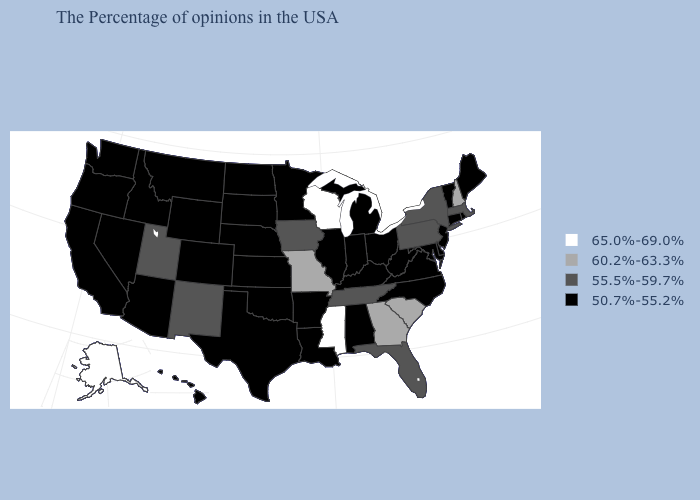Which states hav the highest value in the West?
Write a very short answer. Alaska. Name the states that have a value in the range 50.7%-55.2%?
Write a very short answer. Maine, Rhode Island, Vermont, Connecticut, New Jersey, Delaware, Maryland, Virginia, North Carolina, West Virginia, Ohio, Michigan, Kentucky, Indiana, Alabama, Illinois, Louisiana, Arkansas, Minnesota, Kansas, Nebraska, Oklahoma, Texas, South Dakota, North Dakota, Wyoming, Colorado, Montana, Arizona, Idaho, Nevada, California, Washington, Oregon, Hawaii. Does Kentucky have a lower value than Iowa?
Keep it brief. Yes. Does Michigan have the lowest value in the MidWest?
Answer briefly. Yes. Does Mississippi have the highest value in the USA?
Be succinct. Yes. Does Ohio have a lower value than Texas?
Quick response, please. No. What is the value of California?
Quick response, please. 50.7%-55.2%. What is the lowest value in the West?
Concise answer only. 50.7%-55.2%. Which states have the lowest value in the South?
Answer briefly. Delaware, Maryland, Virginia, North Carolina, West Virginia, Kentucky, Alabama, Louisiana, Arkansas, Oklahoma, Texas. What is the value of Michigan?
Be succinct. 50.7%-55.2%. Which states have the lowest value in the USA?
Keep it brief. Maine, Rhode Island, Vermont, Connecticut, New Jersey, Delaware, Maryland, Virginia, North Carolina, West Virginia, Ohio, Michigan, Kentucky, Indiana, Alabama, Illinois, Louisiana, Arkansas, Minnesota, Kansas, Nebraska, Oklahoma, Texas, South Dakota, North Dakota, Wyoming, Colorado, Montana, Arizona, Idaho, Nevada, California, Washington, Oregon, Hawaii. What is the highest value in states that border Vermont?
Answer briefly. 60.2%-63.3%. What is the value of Nebraska?
Keep it brief. 50.7%-55.2%. What is the lowest value in the USA?
Write a very short answer. 50.7%-55.2%. Does Georgia have the same value as New Hampshire?
Concise answer only. Yes. 